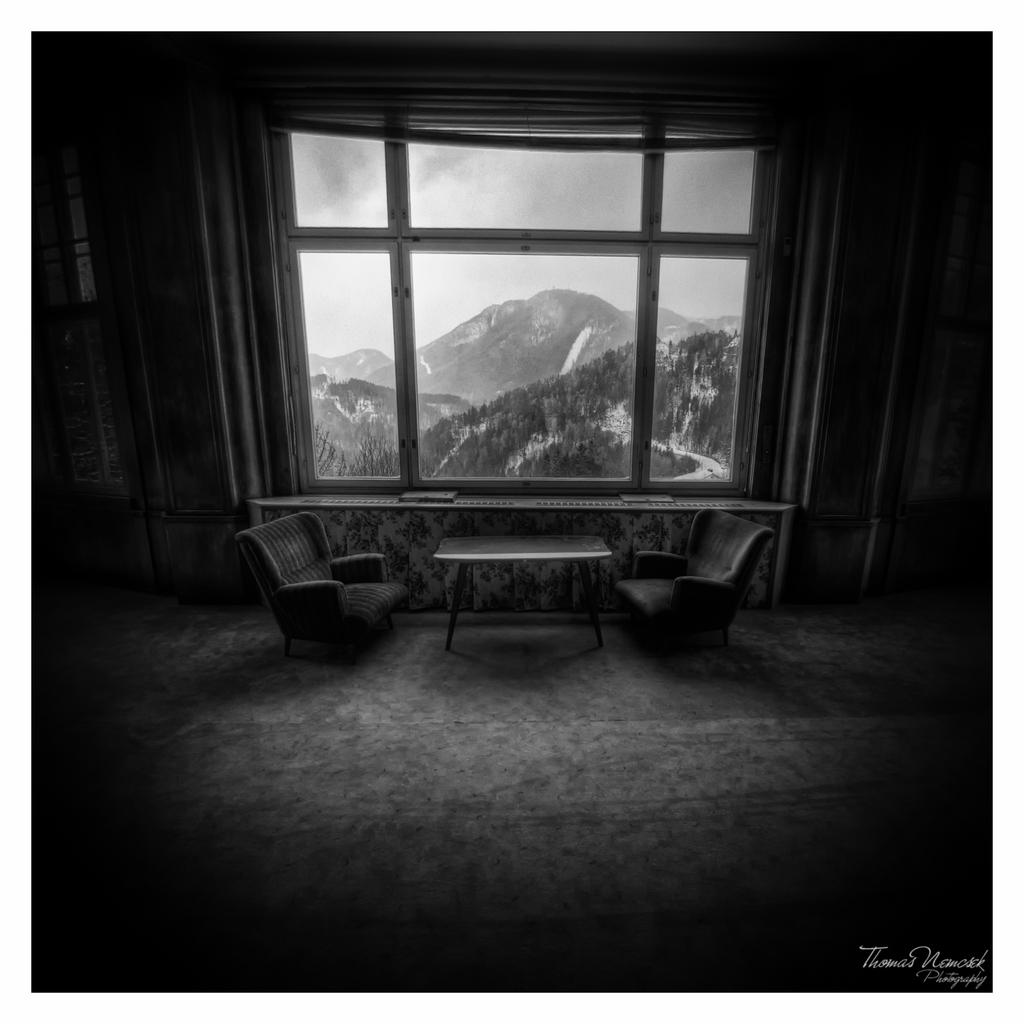What type of location is depicted in the image? The image shows an inner view of a house. How many chairs are present in the house? There are two chairs in the house. What furniture piece can be seen in the image besides the chairs? There is a table in the house. What can be seen outside the house through a window? Hills are visible from a window in the house. Can you see any quicksand outside the window in the image? There is no quicksand visible in the image; only hills can be seen from the window. What type of bird is sitting on the tongue of the person in the image? There is no person or bird present in the image; it shows an inner view of a house with chairs, a table, and a view of hills outside. 